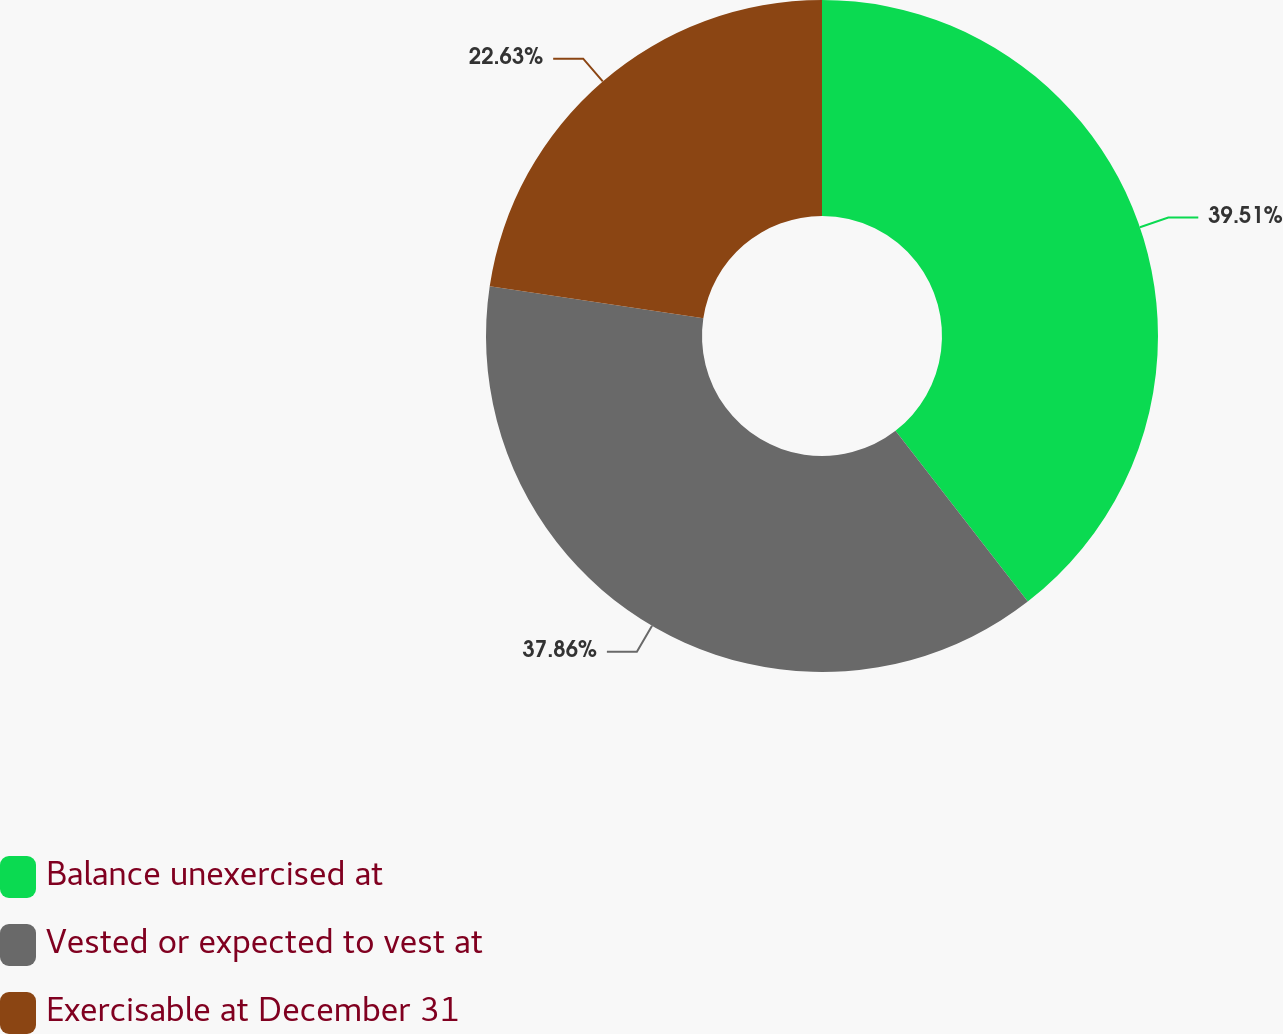<chart> <loc_0><loc_0><loc_500><loc_500><pie_chart><fcel>Balance unexercised at<fcel>Vested or expected to vest at<fcel>Exercisable at December 31<nl><fcel>39.51%<fcel>37.86%<fcel>22.63%<nl></chart> 